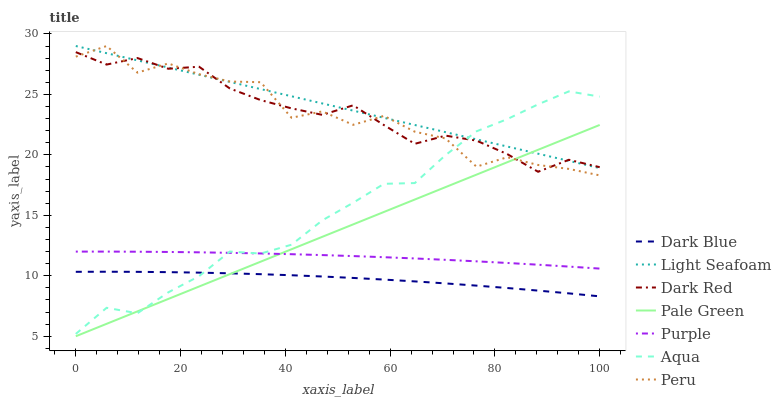Does Dark Blue have the minimum area under the curve?
Answer yes or no. Yes. Does Light Seafoam have the maximum area under the curve?
Answer yes or no. Yes. Does Dark Red have the minimum area under the curve?
Answer yes or no. No. Does Dark Red have the maximum area under the curve?
Answer yes or no. No. Is Pale Green the smoothest?
Answer yes or no. Yes. Is Peru the roughest?
Answer yes or no. Yes. Is Dark Red the smoothest?
Answer yes or no. No. Is Dark Red the roughest?
Answer yes or no. No. Does Dark Red have the lowest value?
Answer yes or no. No. Does Dark Red have the highest value?
Answer yes or no. No. Is Purple less than Dark Red?
Answer yes or no. Yes. Is Peru greater than Purple?
Answer yes or no. Yes. Does Purple intersect Dark Red?
Answer yes or no. No. 